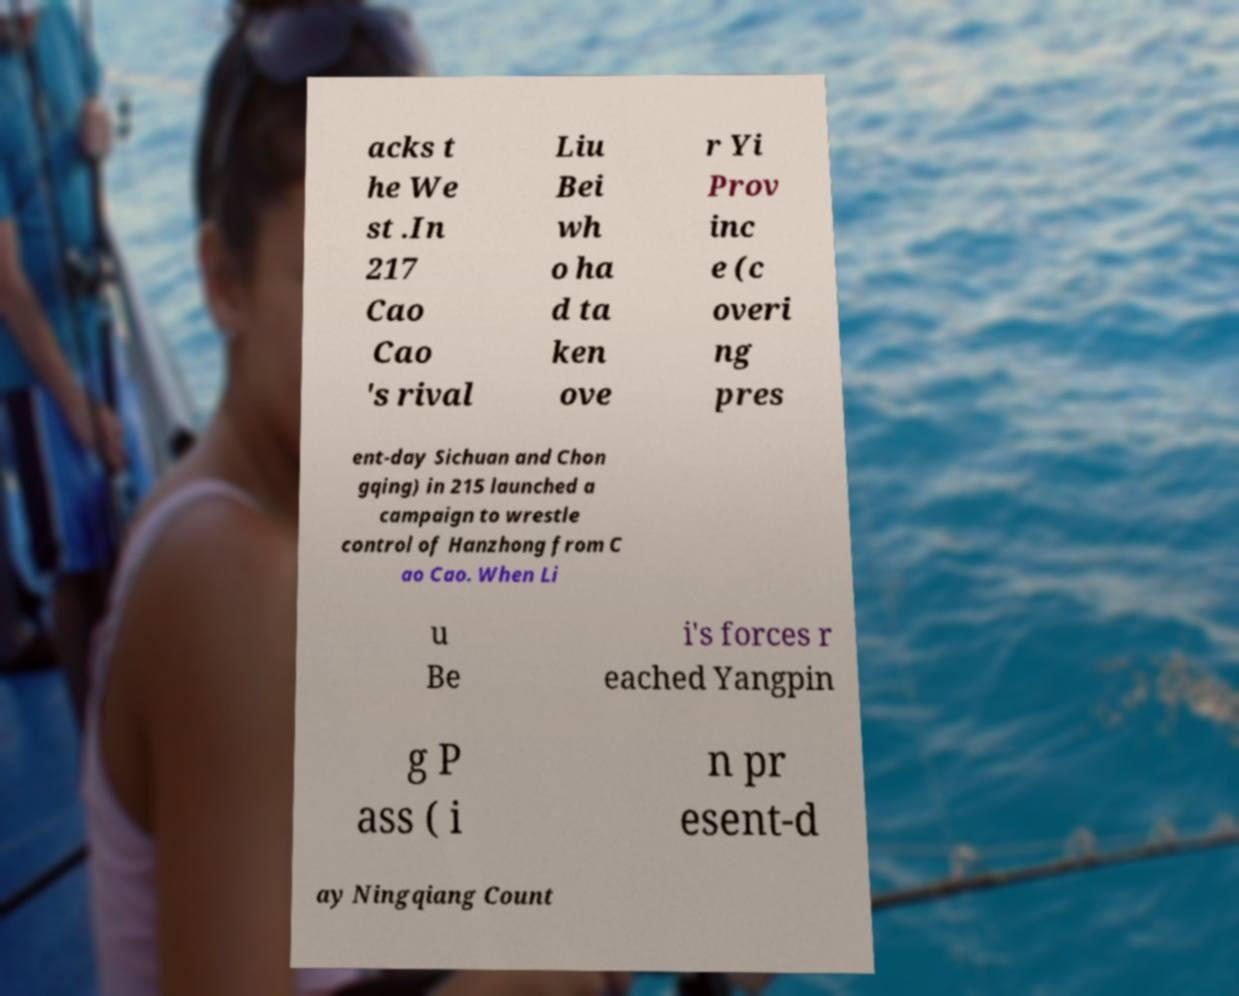Could you extract and type out the text from this image? acks t he We st .In 217 Cao Cao 's rival Liu Bei wh o ha d ta ken ove r Yi Prov inc e (c overi ng pres ent-day Sichuan and Chon gqing) in 215 launched a campaign to wrestle control of Hanzhong from C ao Cao. When Li u Be i's forces r eached Yangpin g P ass ( i n pr esent-d ay Ningqiang Count 